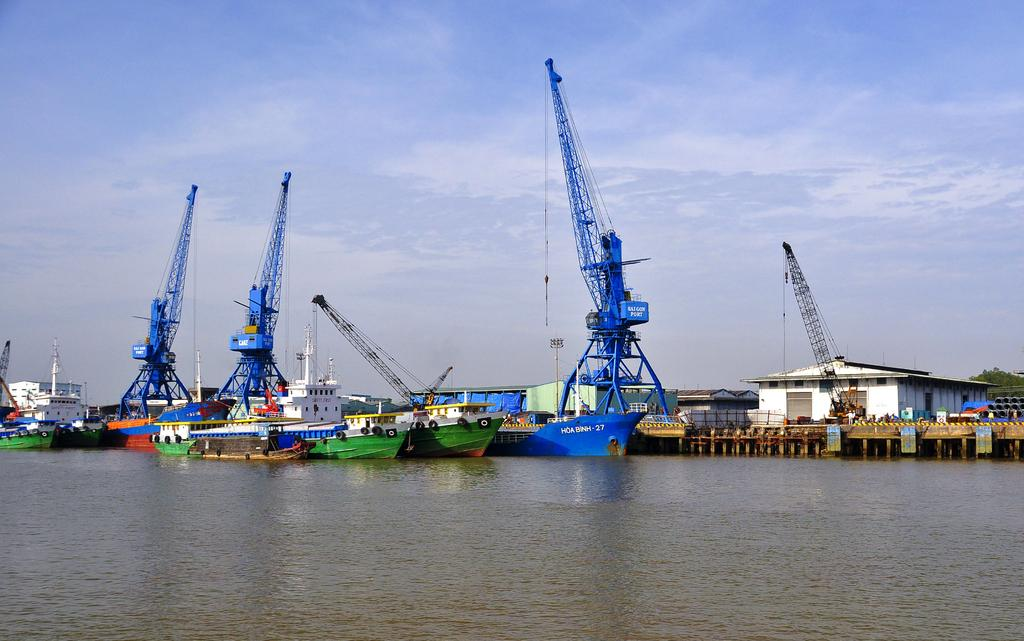What type of location is depicted in the image? There is a shipyard in the image. What can be seen in the shipyard? There are many ships in the image. How are the ships positioned in relation to the bridge? The ships are beside a bridge. What is the bridge built on? The bridge is on a water surface. What features can be seen on the bridge? There are compartments on the bridge. What type of straw is being used to create the bridge in the image? There is no straw present in the image; the bridge is built on a water surface. Does the existence of the bridge in the image prove the existence of a parallel universe? The image does not provide any information about parallel universes, and the existence of the bridge in the image cannot be used to prove or disprove the existence of a parallel universe. 